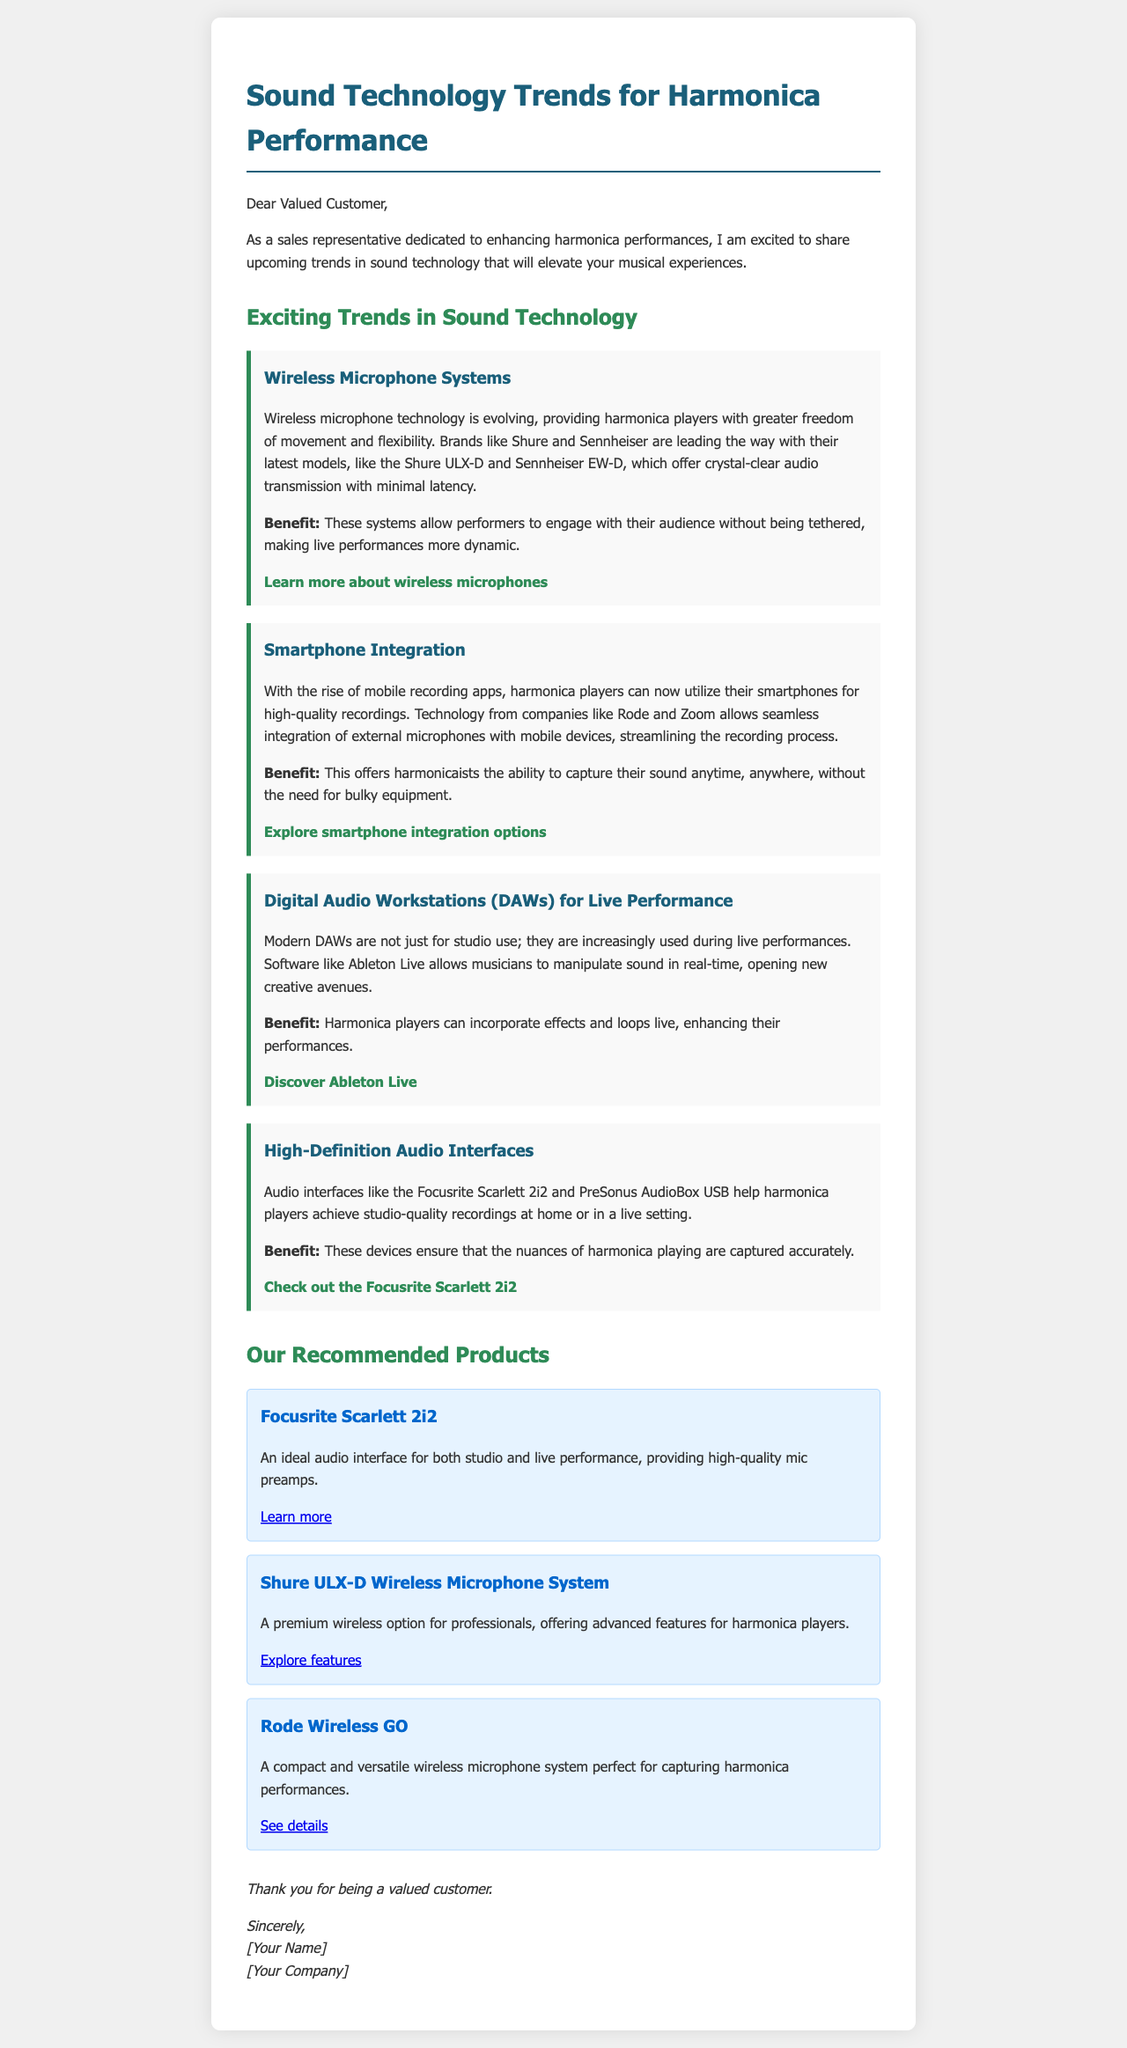What is the title of the document? The title of the document is prominently displayed at the top, indicating the main topic of discussion.
Answer: Sound Technology Trends for Harmonica Performance Who is the letter addressed to? The opening line of the letter specifies the recipient type.
Answer: Valued Customer Name one brand mentioned in the wireless microphone systems trend. The document lists brands in the context of wireless microphone systems.
Answer: Shure What technology is emphasized for integrating harmonica with mobile devices? The smartphone integration section highlights technology related to mobile devices.
Answer: Mobile recording apps What is a benefit of high-definition audio interfaces for harmonica players? The document describes the advantages of using high-definition audio interfaces for harmonica recording.
Answer: Studio-quality recordings What product is recommended for studio and live performance? The recommended products section identifies a specific product ideal for its intended use.
Answer: Focusrite Scarlett 2i2 How many major trends are listed in the document? The document enumerates different trends under the technology section.
Answer: Four Which digital audio workstation is mentioned? The DAW section specifically names a well-known software solution for musicians.
Answer: Ableton Live What color are the product boxes in the document? The design details are described with a focus on their visual attributes.
Answer: Light blue 